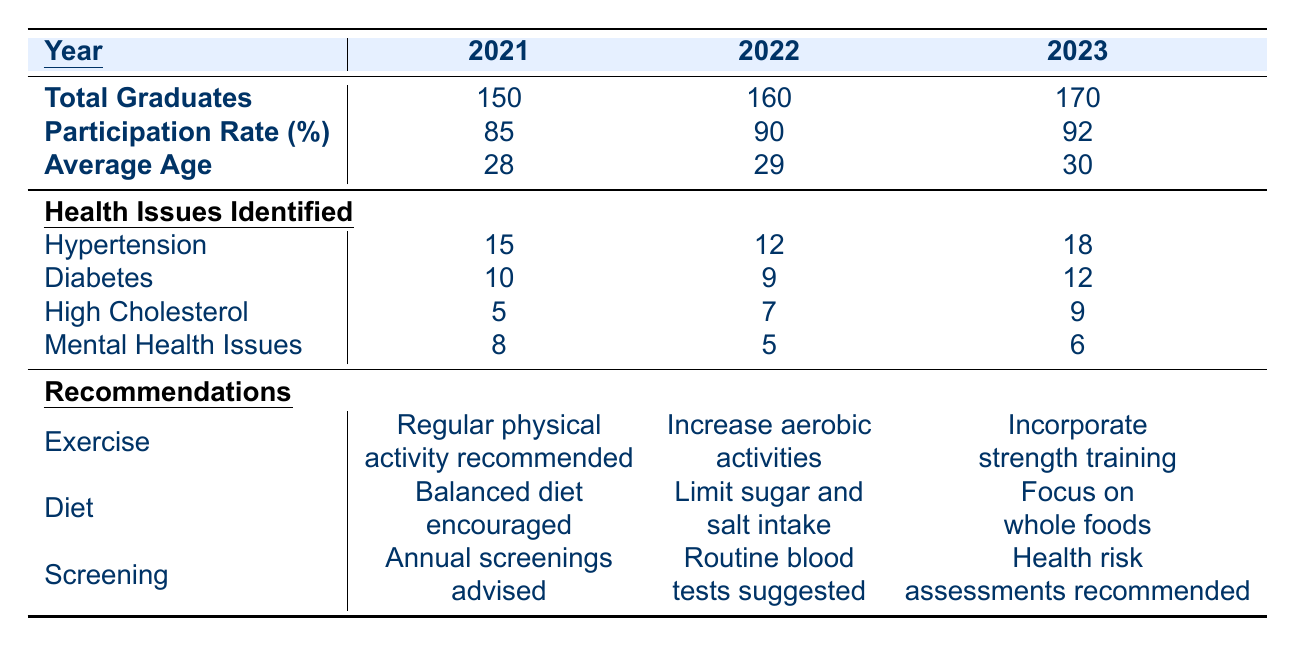What was the total number of graduates in 2022? The table explicitly states that the total number of graduates in 2022 is 160.
Answer: 160 What is the average age of graduates in 2023? According to the table, the average age of graduates in 2023 is 30.
Answer: 30 How many graduates identified with hypertension in 2021? The table indicates that 15 graduates identified with hypertension in 2021.
Answer: 15 What recommendations were made regarding diet in 2022? The table notes that in 2022, the diet recommendation was to limit sugar and salt intake.
Answer: Limit sugar and salt intake What is the difference in participation rate between 2021 and 2023? The participation rate in 2021 is 85% and in 2023 is 92%. The difference is calculated as 92 - 85 = 7.
Answer: 7% Did the average age of graduates increase from 2021 to 2023? Yes, in 2021 the average age was 28, which increased to 30 by 2023.
Answer: Yes What was the total number of health issues identified in 2021? The total health issues for 2021 are calculated by summing the identified issues: 15 (hypertension) + 10 (diabetes) + 5 (high cholesterol) + 8 (mental health) = 38.
Answer: 38 What percentage of graduates participated in the health check-up in 2022? The table indicates that the participation rate for 2022 was 90%.
Answer: 90% Was there an increase in the identification of diabetes from 2021 to 2023? Yes, diabetes cases increased from 10 in 2021 to 12 in 2023, indicating an increase.
Answer: Yes How many health issues were identified for high cholesterol across all three years? Summing together the high cholesterol cases: 5 (2021) + 7 (2022) + 9 (2023) = 21.
Answer: 21 Which year had the highest recommendation in exercise? In 2023, the recommendation was to incorporate strength training, which is a more specific and possibly heightened recommendation compared to the previous years.
Answer: 2023 